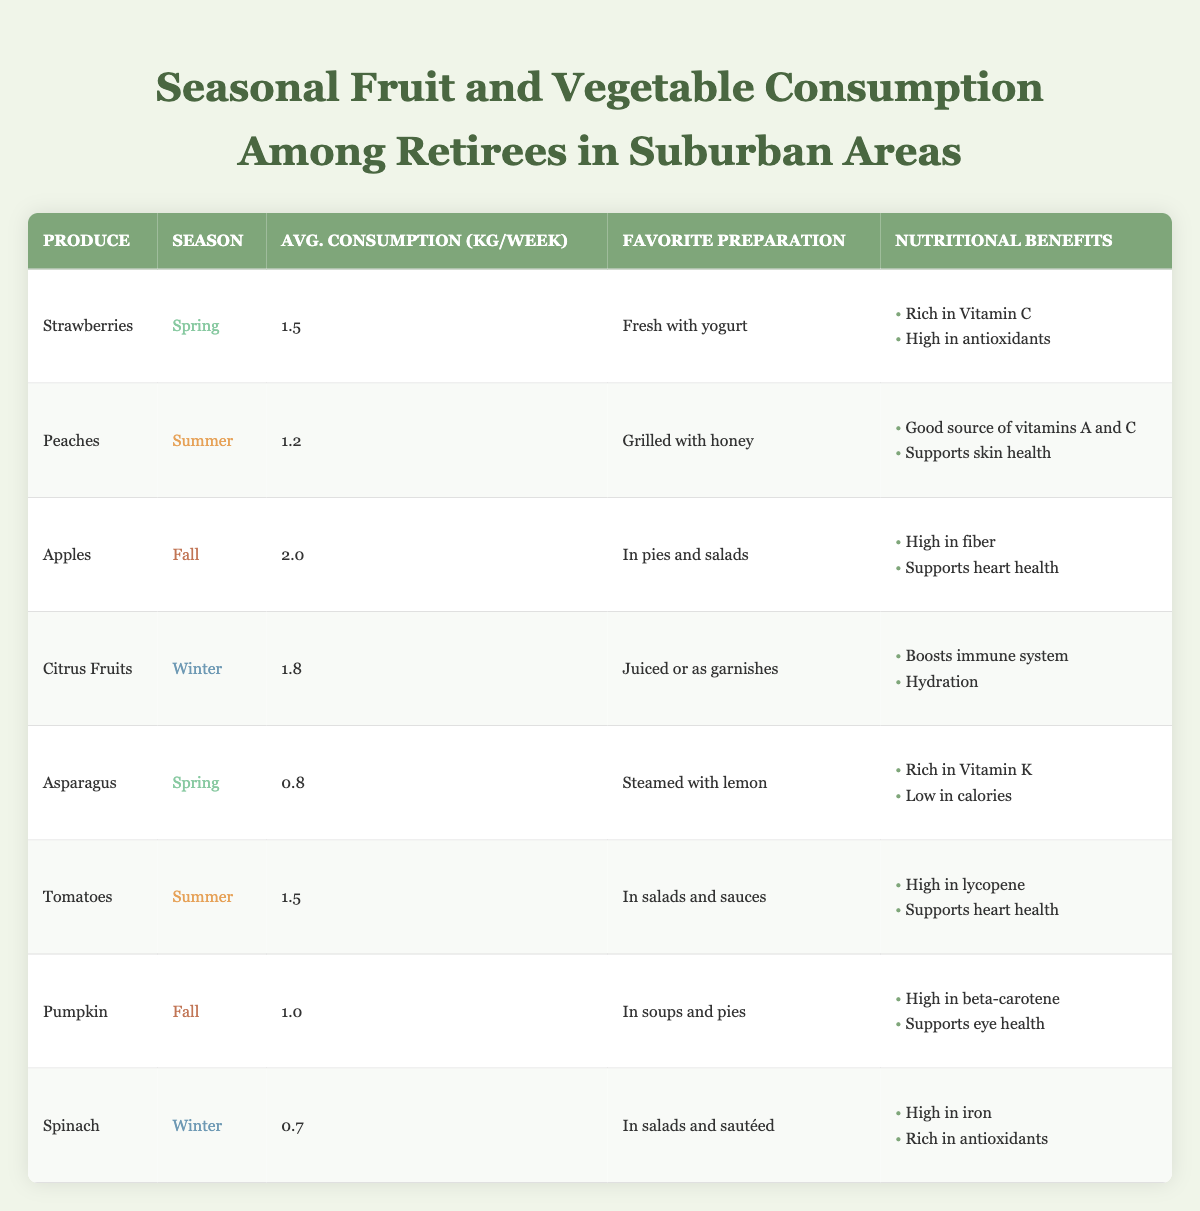What is the average consumption of apples per week? The table indicates that apples have an average consumption of 2.0 kg per week. You can find this value directly listed in the "Avg. Consumption (kg/week)" column for apples.
Answer: 2.0 kg Which vegetable has the highest average consumption per week? By reviewing the "Avg. Consumption (kg/week)" column for vegetables—Asparagus (0.8 kg), Tomatoes (1.5 kg), Pumpkin (1.0 kg), and Spinach (0.7 kg)—it's clear that Tomatoes have the highest average at 1.5 kg.
Answer: Tomatoes Is it true that strawberries are consumed more than peaches? The average consumption per week for strawberries is 1.5 kg, while for peaches it is 1.2 kg. Since 1.5 kg is greater than 1.2 kg, the statement is true.
Answer: Yes What is the total average consumption of fruits during fall? In the fall, the fruits listed are apples (2.0 kg) and pumpkin (not a fruit). Since pumpkin is the only vegetable, we only consider apples. So the total average consumption for fruits in fall is just 2.0 kg from apples.
Answer: 2.0 kg Which season has the highest average fruit consumption, and what is the value? The average consumptions for fruits are: Strawberries (1.5 kg in Spring), Peaches (1.2 kg in Summer), Apples (2.0 kg in Fall), and Citrus Fruits (1.8 kg in Winter). The highest is for Apples in Fall at 2.0 kg.
Answer: Fall, 2.0 kg How much more does the average consumption of citrus fruits exceed that of spinach? Citrus Fruits have an average consumption of 1.8 kg, and Spinach has 0.7 kg. To find the difference, subtract the spinach consumption from that of the citrus fruits: 1.8 kg - 0.7 kg = 1.1 kg.
Answer: 1.1 kg Are there any vegetables consumed more than 1.0 kg per week? The vegetables listed are Asparagus (0.8 kg), Tomatoes (1.5 kg), Pumpkin (1.0 kg), and Spinach (0.7 kg). Since Tomatoes (1.5 kg) and Pumpkin (1.0 kg) are at or above the 1.0 kg mark, the answer is yes.
Answer: Yes What is the combined average weekly consumption of summer fruits and vegetables? In summer, we have Peaches (1.2 kg) and Tomatoes (1.5 kg). The combined average is found by adding these two: 1.2 kg + 1.5 kg = 2.7 kg.
Answer: 2.7 kg Which fruit's favorite preparation involves grilling? The table shows that Peaches have a favorite preparation of "Grilled with honey." This is distinct from the other fruits listed, which have different preparations.
Answer: Peaches 